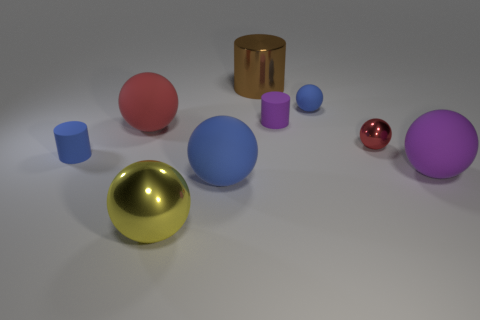Subtract all blue spheres. How many spheres are left? 4 Subtract all red metal balls. How many balls are left? 5 Subtract 1 balls. How many balls are left? 5 Subtract all cyan spheres. Subtract all green blocks. How many spheres are left? 6 Add 1 cyan cylinders. How many objects exist? 10 Subtract all cylinders. How many objects are left? 6 Subtract 1 purple cylinders. How many objects are left? 8 Subtract all tiny red metal things. Subtract all tiny blue rubber objects. How many objects are left? 6 Add 7 tiny purple cylinders. How many tiny purple cylinders are left? 8 Add 3 big purple spheres. How many big purple spheres exist? 4 